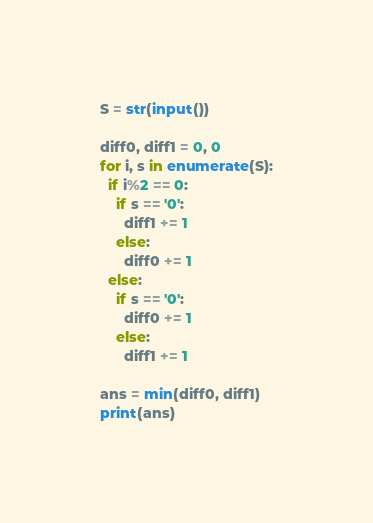Convert code to text. <code><loc_0><loc_0><loc_500><loc_500><_Python_>S = str(input())

diff0, diff1 = 0, 0
for i, s in enumerate(S):
  if i%2 == 0:
    if s == '0':
      diff1 += 1
    else:
      diff0 += 1
  else:
    if s == '0':
      diff0 += 1
    else:
      diff1 += 1

ans = min(diff0, diff1)
print(ans)</code> 